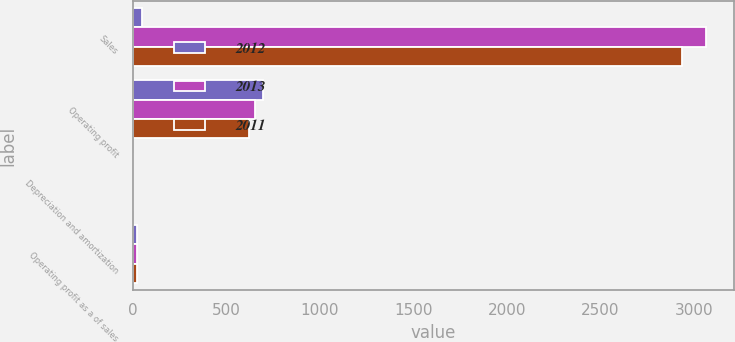<chart> <loc_0><loc_0><loc_500><loc_500><stacked_bar_chart><ecel><fcel>Sales<fcel>Operating profit<fcel>Depreciation and amortization<fcel>Operating profit as a of sales<nl><fcel>2012<fcel>47.4<fcel>696.5<fcel>1.9<fcel>21<nl><fcel>2013<fcel>3063.5<fcel>652.5<fcel>1.6<fcel>21.3<nl><fcel>2011<fcel>2939.6<fcel>622.7<fcel>1.6<fcel>21.2<nl></chart> 